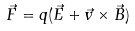Convert formula to latex. <formula><loc_0><loc_0><loc_500><loc_500>\vec { F } = q ( \vec { E } + \vec { v } \times \vec { B } )</formula> 